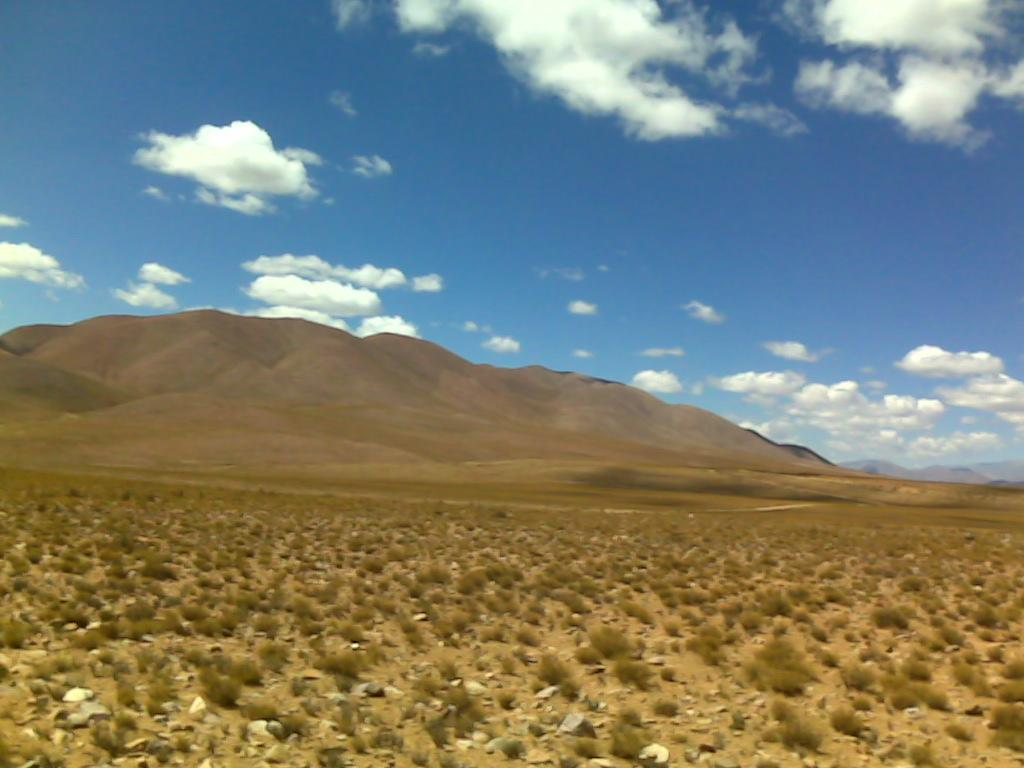What type of vegetation can be seen in the image? There are plants in the image. Where are the plants located? The plants are on the land. What can be seen in the background of the image? There is a hill visible in the background of the image. What type of environment is depicted in the image? The landscape appears to be a desert. What is visible in the sky in the image? The sky is visible in the image, and clouds are present. Can you see a clam in the desert landscape of the image? No, there are no clams present in the image; it depicts a desert landscape with plants and a hill in the background. 